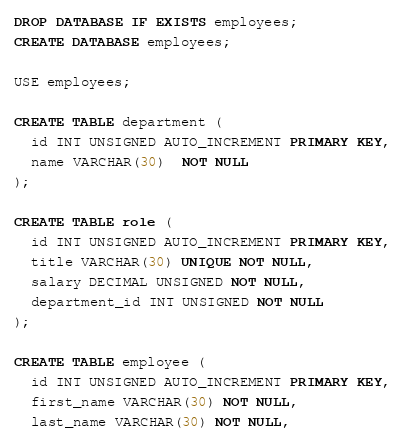Convert code to text. <code><loc_0><loc_0><loc_500><loc_500><_SQL_>DROP DATABASE IF EXISTS employees;
CREATE DATABASE employees;

USE employees;

CREATE TABLE department (
  id INT UNSIGNED AUTO_INCREMENT PRIMARY KEY,
  name VARCHAR(30)  NOT NULL
);

CREATE TABLE role (
  id INT UNSIGNED AUTO_INCREMENT PRIMARY KEY,
  title VARCHAR(30) UNIQUE NOT NULL,
  salary DECIMAL UNSIGNED NOT NULL,
  department_id INT UNSIGNED NOT NULL
);

CREATE TABLE employee (
  id INT UNSIGNED AUTO_INCREMENT PRIMARY KEY,
  first_name VARCHAR(30) NOT NULL,
  last_name VARCHAR(30) NOT NULL,</code> 